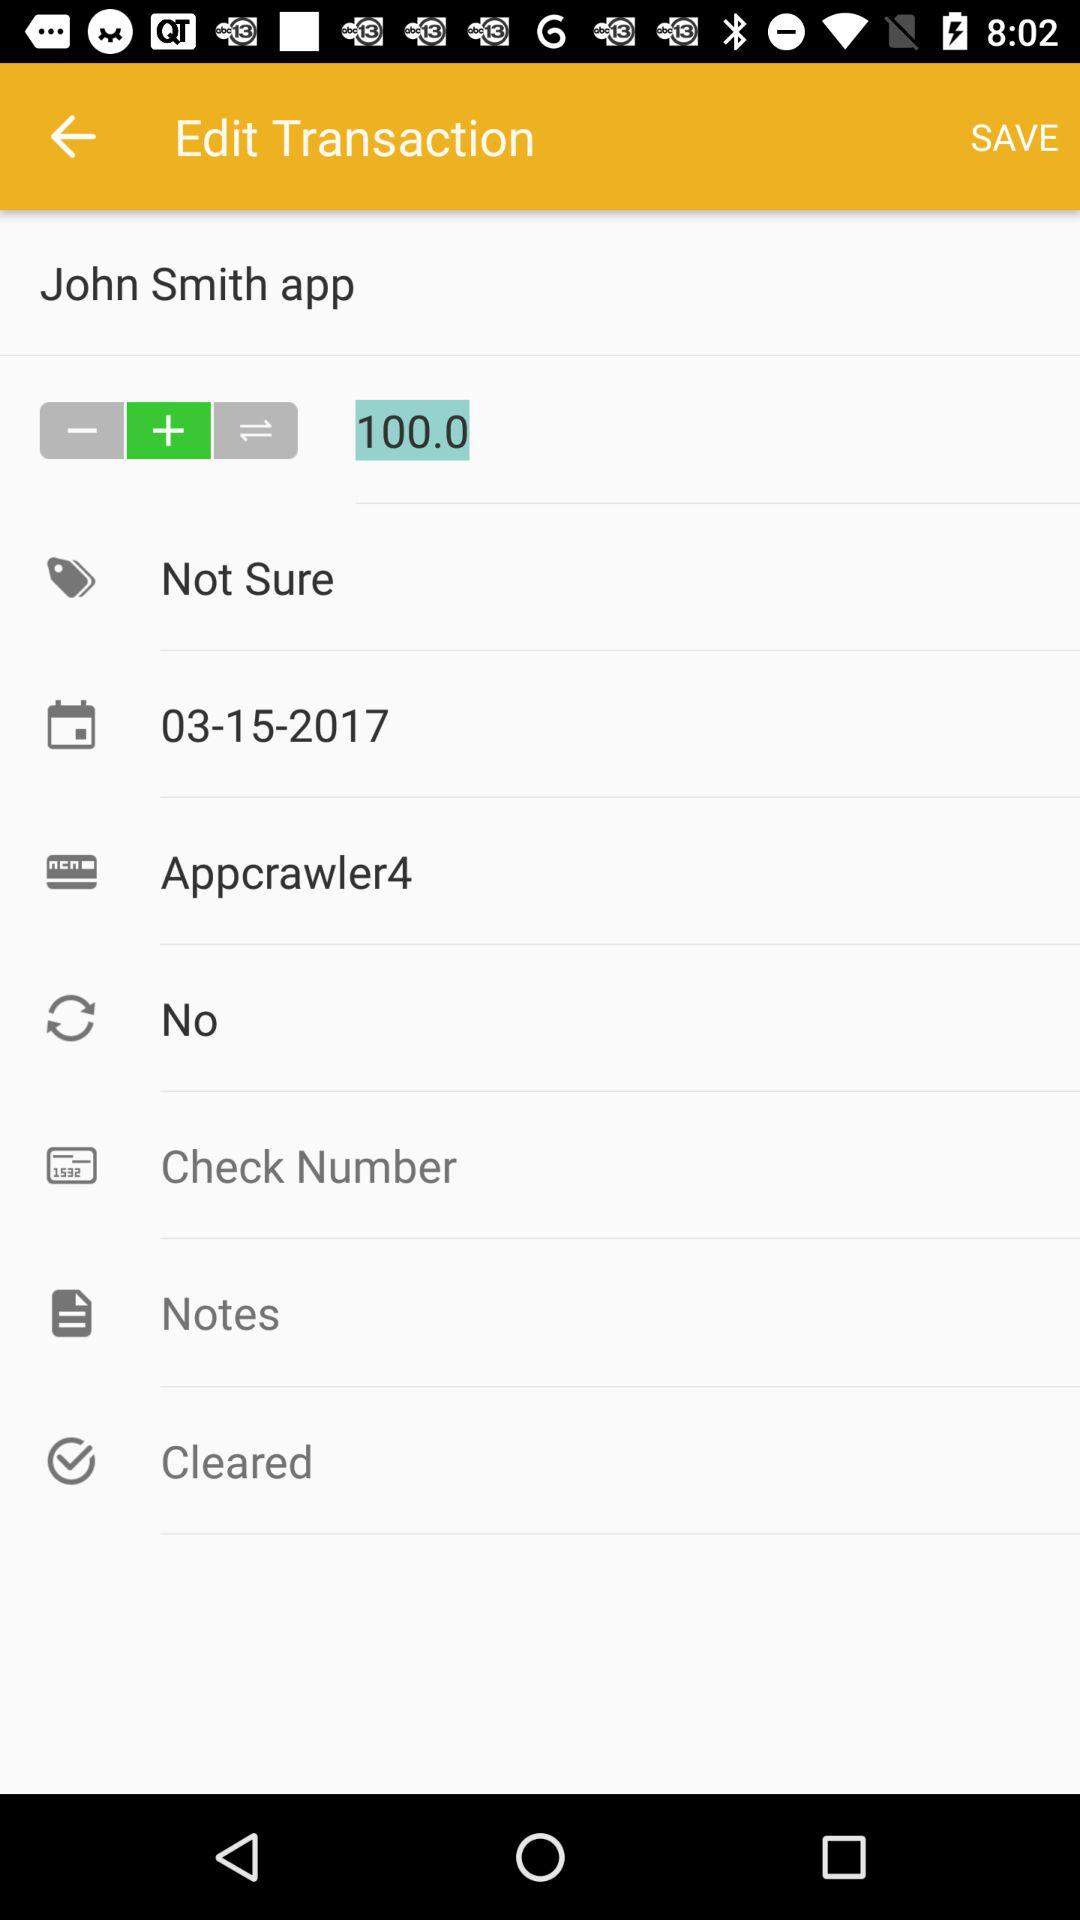How much is the amount of this transaction?
Answer the question using a single word or phrase. 100.0 